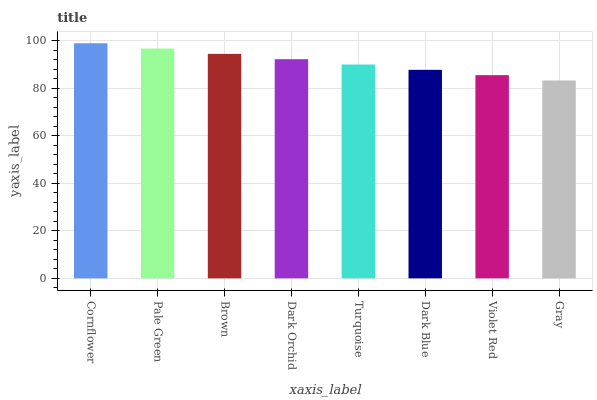Is Gray the minimum?
Answer yes or no. Yes. Is Cornflower the maximum?
Answer yes or no. Yes. Is Pale Green the minimum?
Answer yes or no. No. Is Pale Green the maximum?
Answer yes or no. No. Is Cornflower greater than Pale Green?
Answer yes or no. Yes. Is Pale Green less than Cornflower?
Answer yes or no. Yes. Is Pale Green greater than Cornflower?
Answer yes or no. No. Is Cornflower less than Pale Green?
Answer yes or no. No. Is Dark Orchid the high median?
Answer yes or no. Yes. Is Turquoise the low median?
Answer yes or no. Yes. Is Turquoise the high median?
Answer yes or no. No. Is Brown the low median?
Answer yes or no. No. 